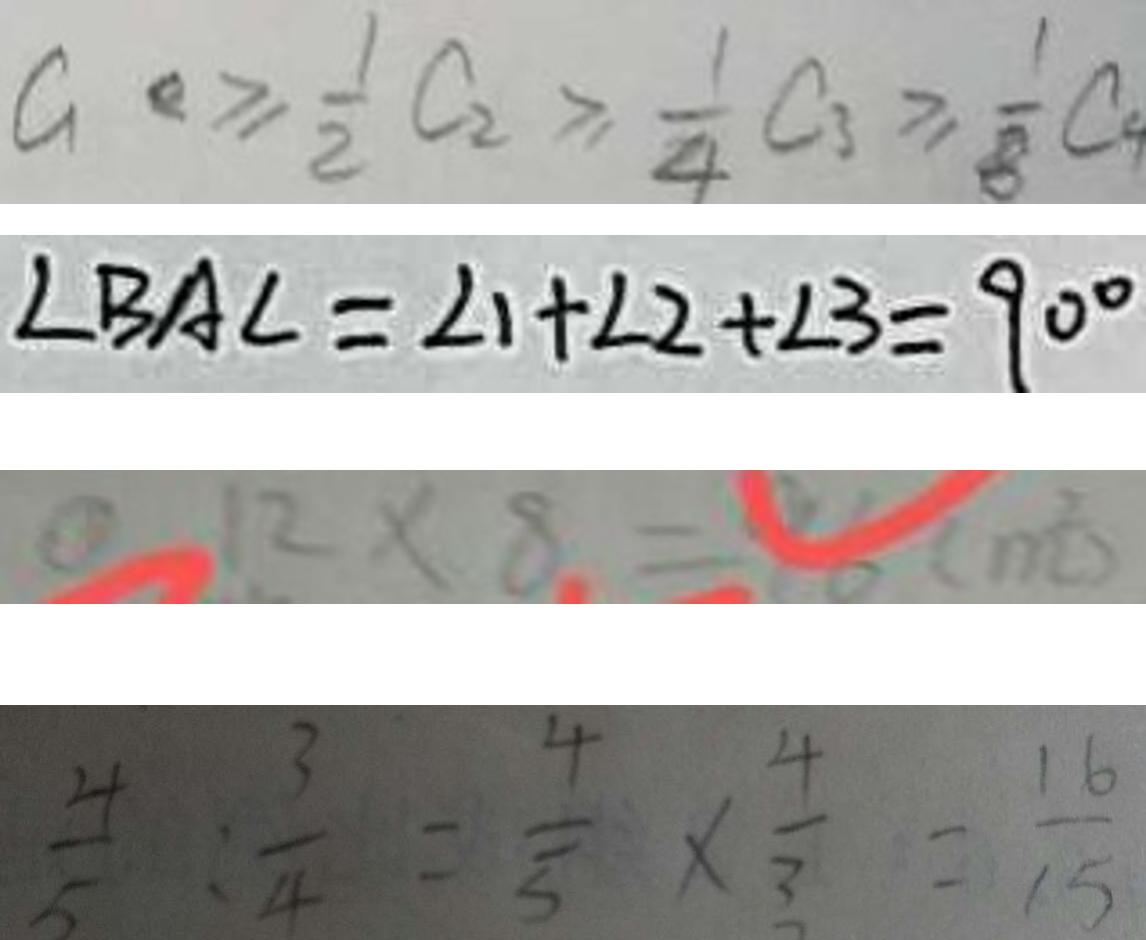<formula> <loc_0><loc_0><loc_500><loc_500>a \geq \frac { 1 } { 2 } C _ { 2 } \geq \frac { 1 } { 4 } C _ { 3 } \geq \frac { 1 } { 8 } C 
 \angle B A C = \angle 1 + \angle 2 + \angle 3 = 9 0 ^ { \circ } 
 1 2 \times 8 = 9 6 ( m ^ { 2 } ) 
 \frac { 4 } { 5 } : \frac { 3 } { 4 } = \frac { 4 } { 5 } \times \frac { 4 } { 3 } = \frac { 1 6 } { 1 5 }</formula> 